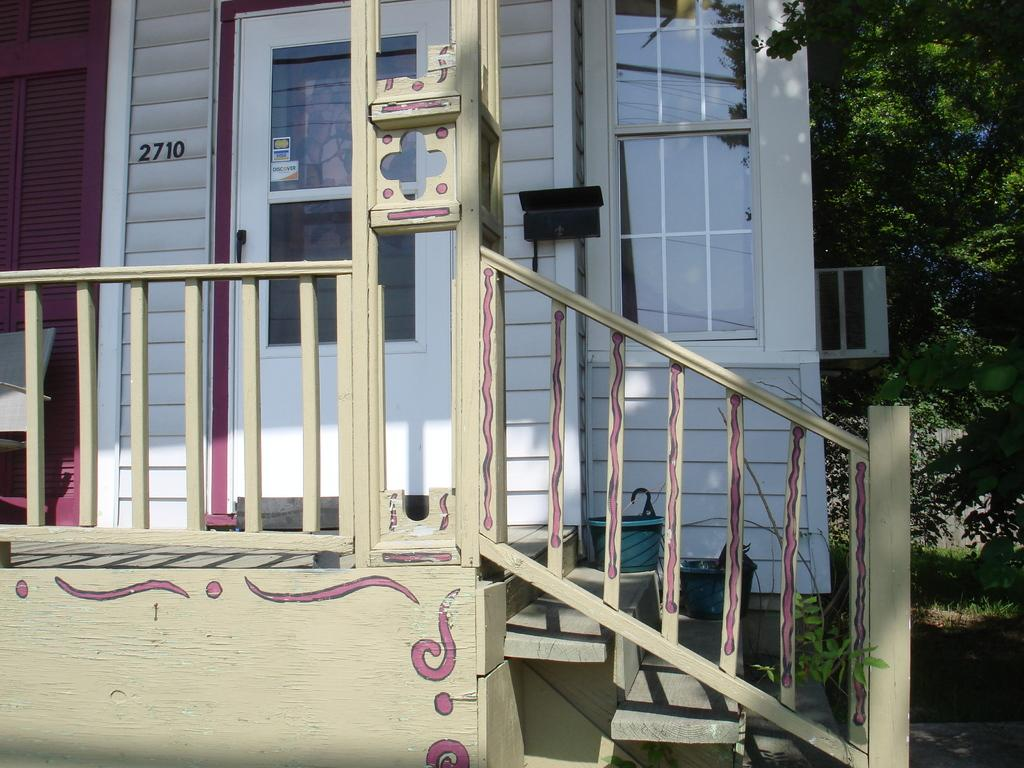What is the main structure in the center of the image? There is a house in the center of the image. Can you describe any entry points in the image? There is a door in the image. What type of barrier surrounds the house? There is a fence in the image. Are there any furniture items visible in the image? Yes, there is a chair in the image. What type of container is present in the image? There is a glass in the image. Can you describe any architectural features in the image? There is a staircase in the image. What type of surface is present on the walls? There is a wall in the image. Are there any plants visible in the image? Yes, there is a plant in the image. What can be seen in the background of the image? There are trees and grass in the background of the image. Are there any other objects visible in the image? Yes, there are other objects in the image. Where is the car parked in the image? There is no car present in the image. What type of food is being served in the lunchroom in the image? There is no lunchroom present in the image. 